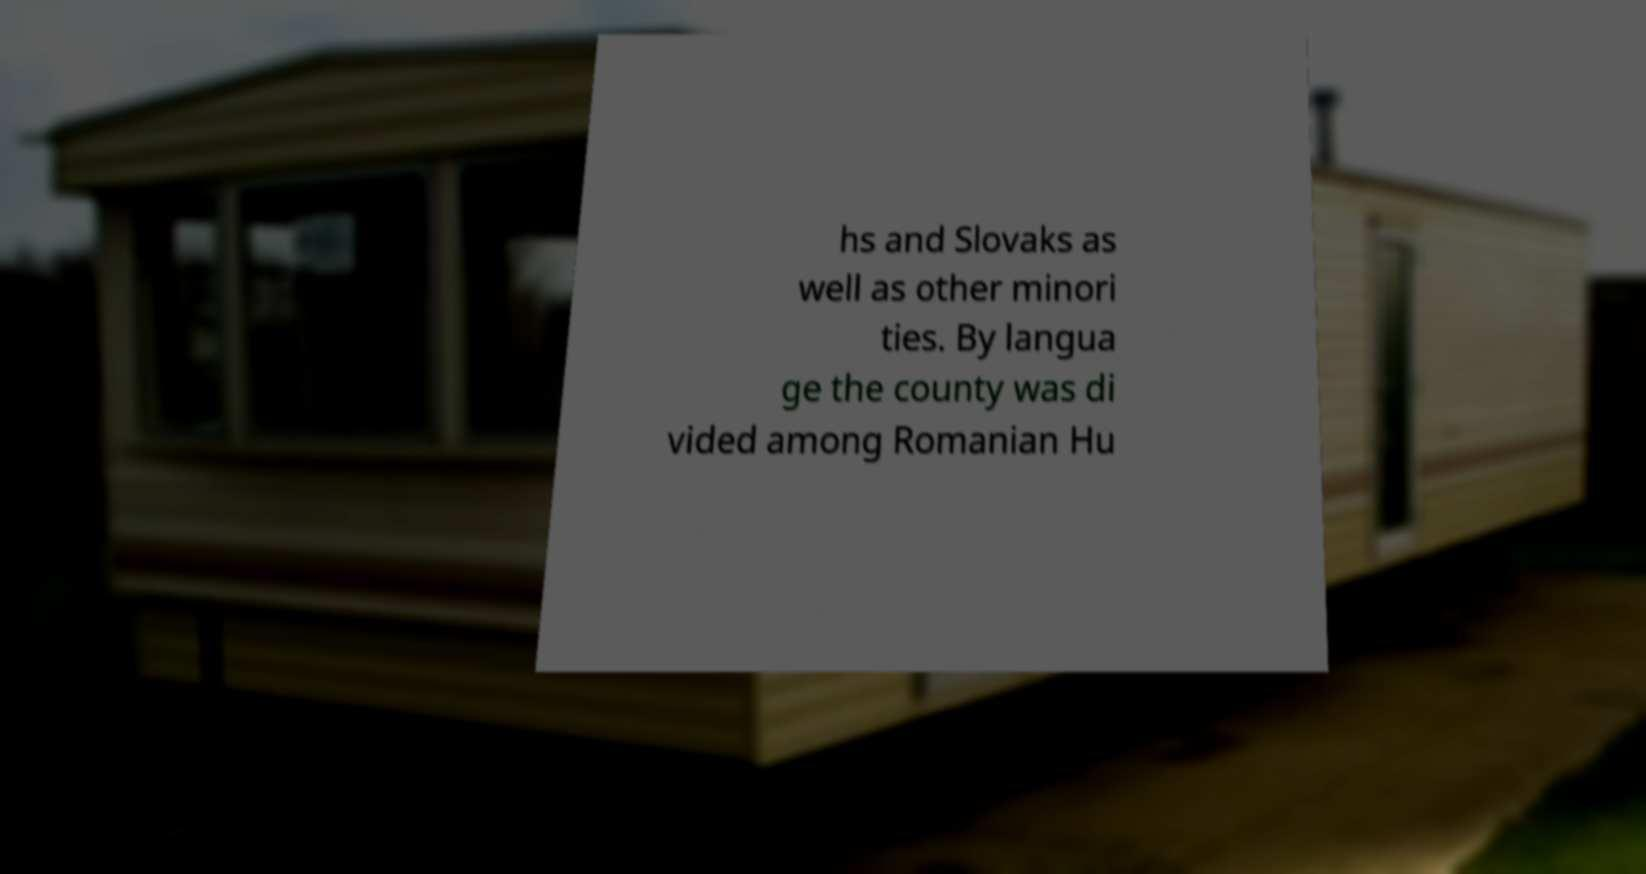Could you assist in decoding the text presented in this image and type it out clearly? hs and Slovaks as well as other minori ties. By langua ge the county was di vided among Romanian Hu 